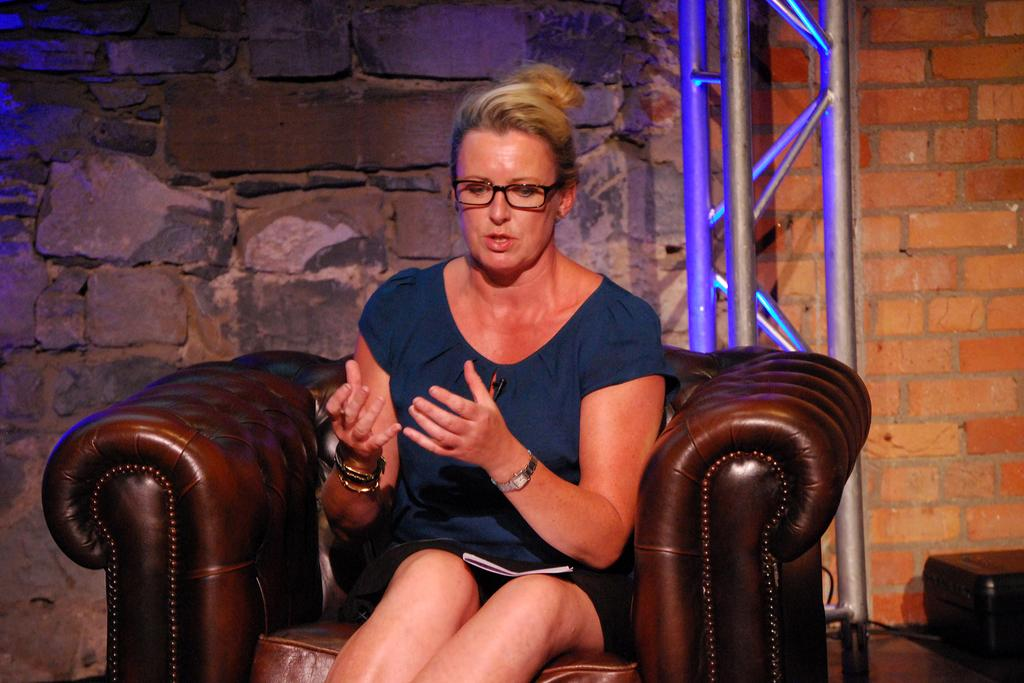Who is the main subject in the image? There is a woman in the image. What is the woman doing in the image? The woman is sitting on a chair. What can be seen in the background of the image? There are poles and a wall in the background of the image. Are there any other objects visible in the background? Yes, there are other objects on the floor in the background of the image. What type of print can be seen on the market in the image? There is no market or print present in the image; it features a woman sitting on a chair with a background of poles and a wall. 